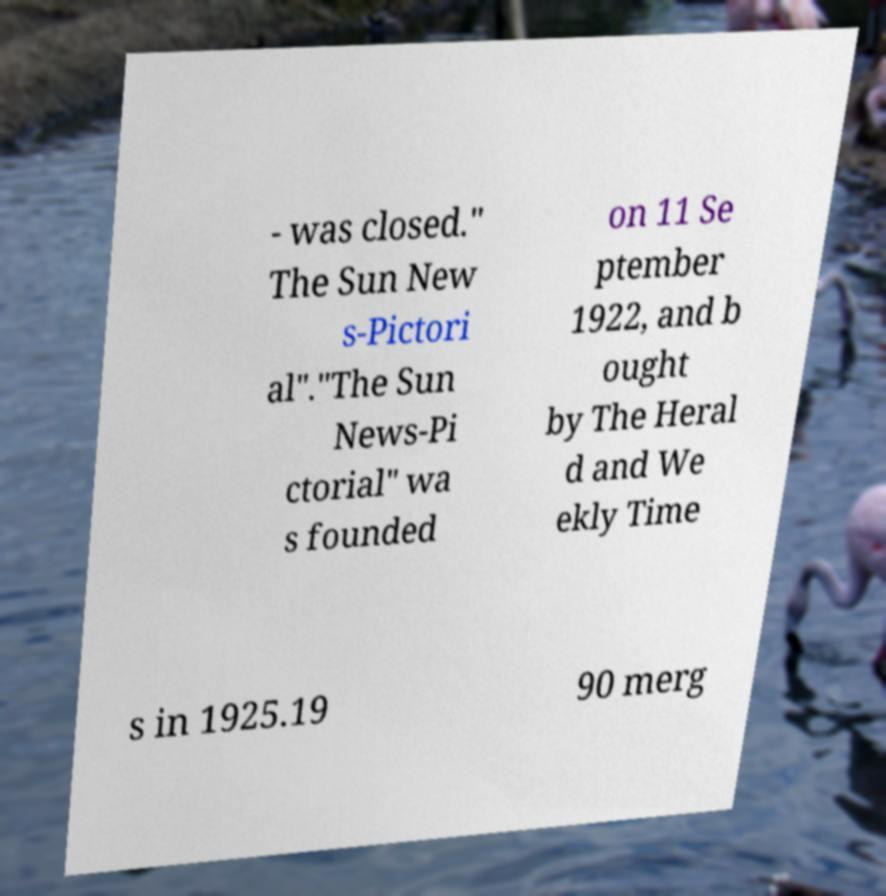There's text embedded in this image that I need extracted. Can you transcribe it verbatim? - was closed." The Sun New s-Pictori al"."The Sun News-Pi ctorial" wa s founded on 11 Se ptember 1922, and b ought by The Heral d and We ekly Time s in 1925.19 90 merg 